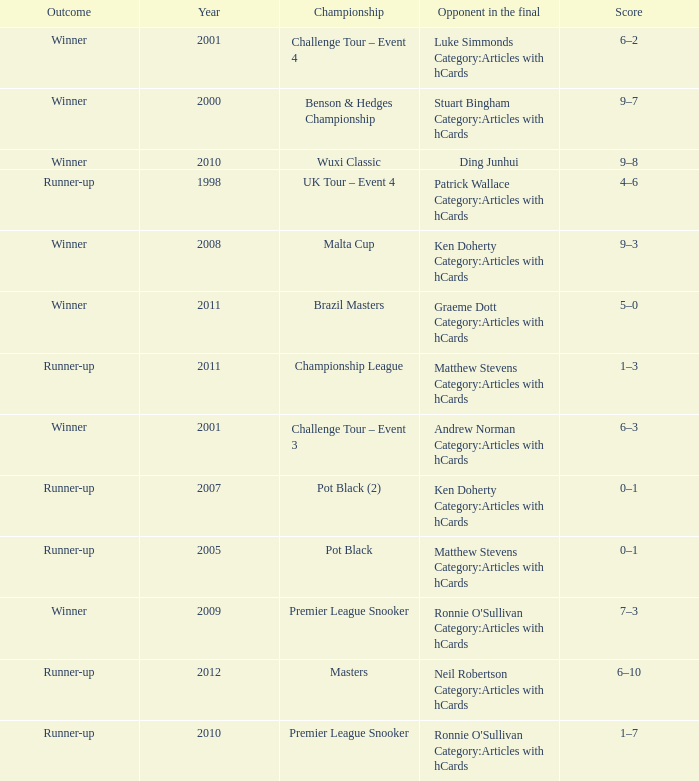What was Shaun Murphy's outcome in the Premier League Snooker championship held before 2010? Winner. 